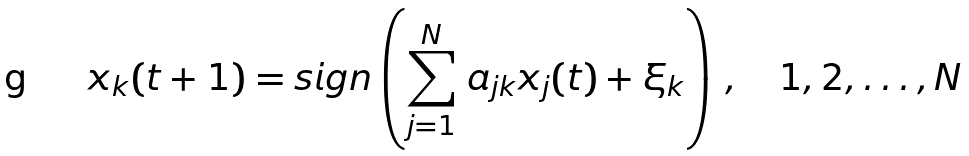<formula> <loc_0><loc_0><loc_500><loc_500>x _ { k } ( t + 1 ) = s i g n \left ( \sum _ { j = 1 } ^ { N } \, a _ { j k } x _ { j } ( t ) + \xi _ { k } \right ) \, , \quad 1 , 2 , \dots , N</formula> 